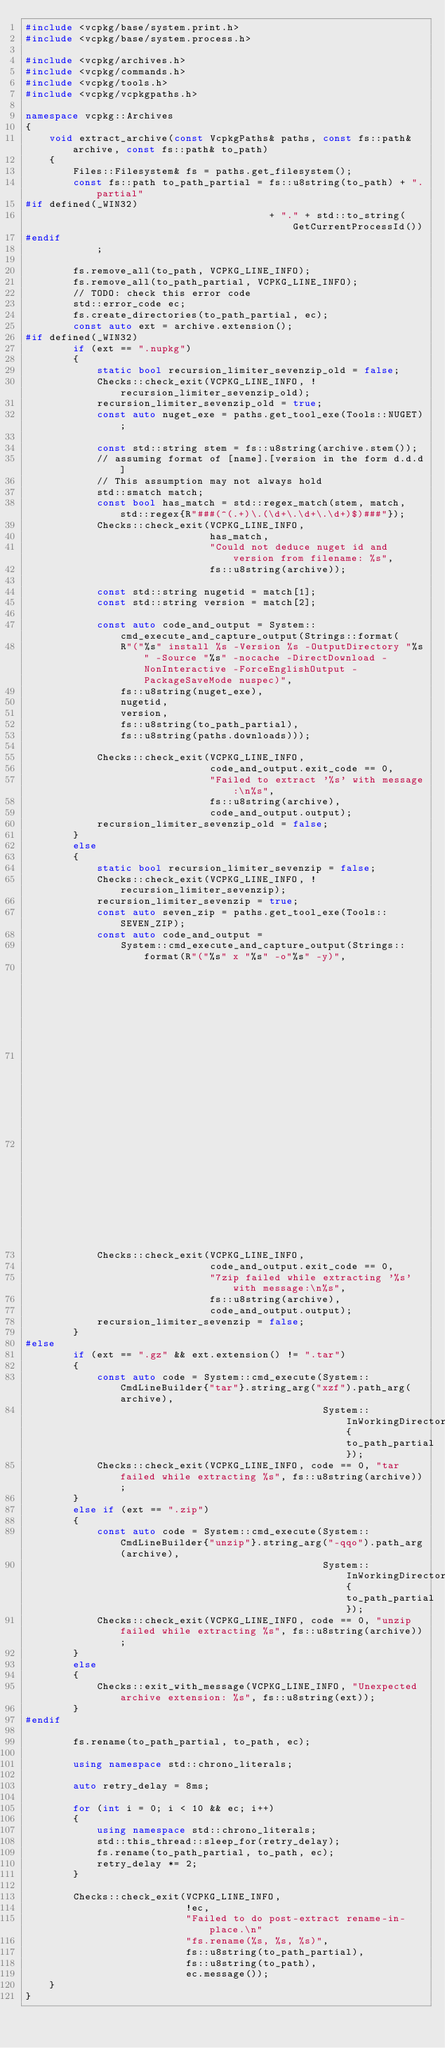<code> <loc_0><loc_0><loc_500><loc_500><_C++_>#include <vcpkg/base/system.print.h>
#include <vcpkg/base/system.process.h>

#include <vcpkg/archives.h>
#include <vcpkg/commands.h>
#include <vcpkg/tools.h>
#include <vcpkg/vcpkgpaths.h>

namespace vcpkg::Archives
{
    void extract_archive(const VcpkgPaths& paths, const fs::path& archive, const fs::path& to_path)
    {
        Files::Filesystem& fs = paths.get_filesystem();
        const fs::path to_path_partial = fs::u8string(to_path) + ".partial"
#if defined(_WIN32)
                                         + "." + std::to_string(GetCurrentProcessId())
#endif
            ;

        fs.remove_all(to_path, VCPKG_LINE_INFO);
        fs.remove_all(to_path_partial, VCPKG_LINE_INFO);
        // TODO: check this error code
        std::error_code ec;
        fs.create_directories(to_path_partial, ec);
        const auto ext = archive.extension();
#if defined(_WIN32)
        if (ext == ".nupkg")
        {
            static bool recursion_limiter_sevenzip_old = false;
            Checks::check_exit(VCPKG_LINE_INFO, !recursion_limiter_sevenzip_old);
            recursion_limiter_sevenzip_old = true;
            const auto nuget_exe = paths.get_tool_exe(Tools::NUGET);

            const std::string stem = fs::u8string(archive.stem());
            // assuming format of [name].[version in the form d.d.d]
            // This assumption may not always hold
            std::smatch match;
            const bool has_match = std::regex_match(stem, match, std::regex{R"###(^(.+)\.(\d+\.\d+\.\d+)$)###"});
            Checks::check_exit(VCPKG_LINE_INFO,
                               has_match,
                               "Could not deduce nuget id and version from filename: %s",
                               fs::u8string(archive));

            const std::string nugetid = match[1];
            const std::string version = match[2];

            const auto code_and_output = System::cmd_execute_and_capture_output(Strings::format(
                R"("%s" install %s -Version %s -OutputDirectory "%s" -Source "%s" -nocache -DirectDownload -NonInteractive -ForceEnglishOutput -PackageSaveMode nuspec)",
                fs::u8string(nuget_exe),
                nugetid,
                version,
                fs::u8string(to_path_partial),
                fs::u8string(paths.downloads)));

            Checks::check_exit(VCPKG_LINE_INFO,
                               code_and_output.exit_code == 0,
                               "Failed to extract '%s' with message:\n%s",
                               fs::u8string(archive),
                               code_and_output.output);
            recursion_limiter_sevenzip_old = false;
        }
        else
        {
            static bool recursion_limiter_sevenzip = false;
            Checks::check_exit(VCPKG_LINE_INFO, !recursion_limiter_sevenzip);
            recursion_limiter_sevenzip = true;
            const auto seven_zip = paths.get_tool_exe(Tools::SEVEN_ZIP);
            const auto code_and_output =
                System::cmd_execute_and_capture_output(Strings::format(R"("%s" x "%s" -o"%s" -y)",
                                                                       fs::u8string(seven_zip),
                                                                       fs::u8string(archive),
                                                                       fs::u8string(to_path_partial)));
            Checks::check_exit(VCPKG_LINE_INFO,
                               code_and_output.exit_code == 0,
                               "7zip failed while extracting '%s' with message:\n%s",
                               fs::u8string(archive),
                               code_and_output.output);
            recursion_limiter_sevenzip = false;
        }
#else
        if (ext == ".gz" && ext.extension() != ".tar")
        {
            const auto code = System::cmd_execute(System::CmdLineBuilder{"tar"}.string_arg("xzf").path_arg(archive),
                                                  System::InWorkingDirectory{to_path_partial});
            Checks::check_exit(VCPKG_LINE_INFO, code == 0, "tar failed while extracting %s", fs::u8string(archive));
        }
        else if (ext == ".zip")
        {
            const auto code = System::cmd_execute(System::CmdLineBuilder{"unzip"}.string_arg("-qqo").path_arg(archive),
                                                  System::InWorkingDirectory{to_path_partial});
            Checks::check_exit(VCPKG_LINE_INFO, code == 0, "unzip failed while extracting %s", fs::u8string(archive));
        }
        else
        {
            Checks::exit_with_message(VCPKG_LINE_INFO, "Unexpected archive extension: %s", fs::u8string(ext));
        }
#endif

        fs.rename(to_path_partial, to_path, ec);

        using namespace std::chrono_literals;

        auto retry_delay = 8ms;

        for (int i = 0; i < 10 && ec; i++)
        {
            using namespace std::chrono_literals;
            std::this_thread::sleep_for(retry_delay);
            fs.rename(to_path_partial, to_path, ec);
            retry_delay *= 2;
        }

        Checks::check_exit(VCPKG_LINE_INFO,
                           !ec,
                           "Failed to do post-extract rename-in-place.\n"
                           "fs.rename(%s, %s, %s)",
                           fs::u8string(to_path_partial),
                           fs::u8string(to_path),
                           ec.message());
    }
}
</code> 